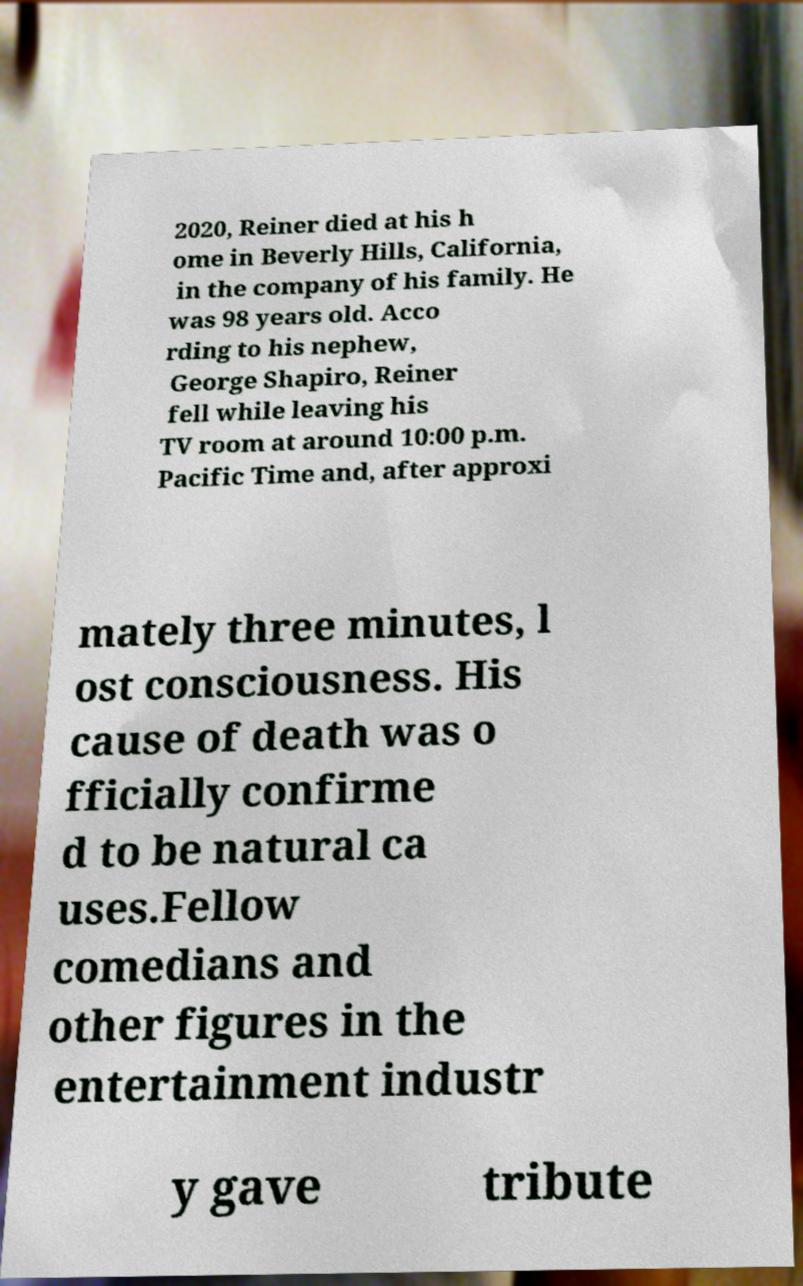Could you extract and type out the text from this image? 2020, Reiner died at his h ome in Beverly Hills, California, in the company of his family. He was 98 years old. Acco rding to his nephew, George Shapiro, Reiner fell while leaving his TV room at around 10:00 p.m. Pacific Time and, after approxi mately three minutes, l ost consciousness. His cause of death was o fficially confirme d to be natural ca uses.Fellow comedians and other figures in the entertainment industr y gave tribute 